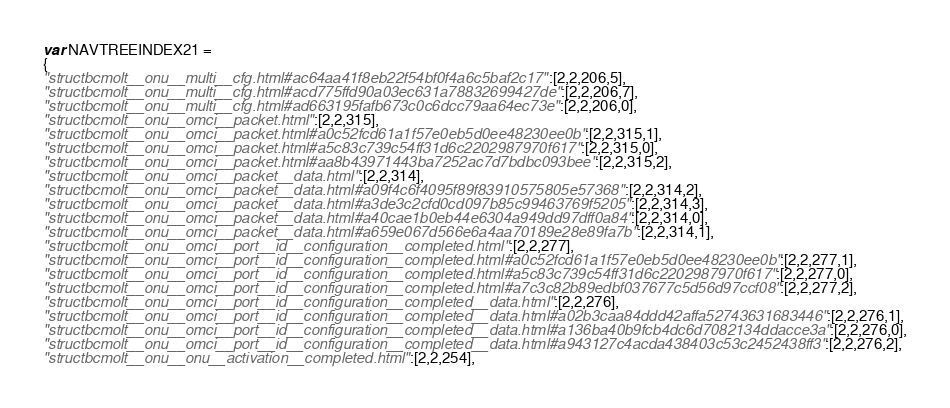Convert code to text. <code><loc_0><loc_0><loc_500><loc_500><_JavaScript_>var NAVTREEINDEX21 =
{
"structbcmolt__onu__multi__cfg.html#ac64aa41f8eb22f54bf0f4a6c5baf2c17":[2,2,206,5],
"structbcmolt__onu__multi__cfg.html#acd775ffd90a03ec631a78832699427de":[2,2,206,7],
"structbcmolt__onu__multi__cfg.html#ad663195fafb673c0c6dcc79aa64ec73e":[2,2,206,0],
"structbcmolt__onu__omci__packet.html":[2,2,315],
"structbcmolt__onu__omci__packet.html#a0c52fcd61a1f57e0eb5d0ee48230ee0b":[2,2,315,1],
"structbcmolt__onu__omci__packet.html#a5c83c739c54ff31d6c2202987970f617":[2,2,315,0],
"structbcmolt__onu__omci__packet.html#aa8b43971443ba7252ac7d7bdbc093bee":[2,2,315,2],
"structbcmolt__onu__omci__packet__data.html":[2,2,314],
"structbcmolt__onu__omci__packet__data.html#a09f4c6f4095f89f83910575805e57368":[2,2,314,2],
"structbcmolt__onu__omci__packet__data.html#a3de3c2cfd0cd097b85c99463769f5205":[2,2,314,3],
"structbcmolt__onu__omci__packet__data.html#a40cae1b0eb44e6304a949dd97dff0a84":[2,2,314,0],
"structbcmolt__onu__omci__packet__data.html#a659e067d566e6a4aa70189e28e89fa7b":[2,2,314,1],
"structbcmolt__onu__omci__port__id__configuration__completed.html":[2,2,277],
"structbcmolt__onu__omci__port__id__configuration__completed.html#a0c52fcd61a1f57e0eb5d0ee48230ee0b":[2,2,277,1],
"structbcmolt__onu__omci__port__id__configuration__completed.html#a5c83c739c54ff31d6c2202987970f617":[2,2,277,0],
"structbcmolt__onu__omci__port__id__configuration__completed.html#a7c3c82b89edbf037677c5d56d97ccf08":[2,2,277,2],
"structbcmolt__onu__omci__port__id__configuration__completed__data.html":[2,2,276],
"structbcmolt__onu__omci__port__id__configuration__completed__data.html#a02b3caa84ddd42affa52743631683446":[2,2,276,1],
"structbcmolt__onu__omci__port__id__configuration__completed__data.html#a136ba40b9fcb4dc6d7082134ddacce3a":[2,2,276,0],
"structbcmolt__onu__omci__port__id__configuration__completed__data.html#a943127c4acda438403c53c2452438ff3":[2,2,276,2],
"structbcmolt__onu__onu__activation__completed.html":[2,2,254],</code> 